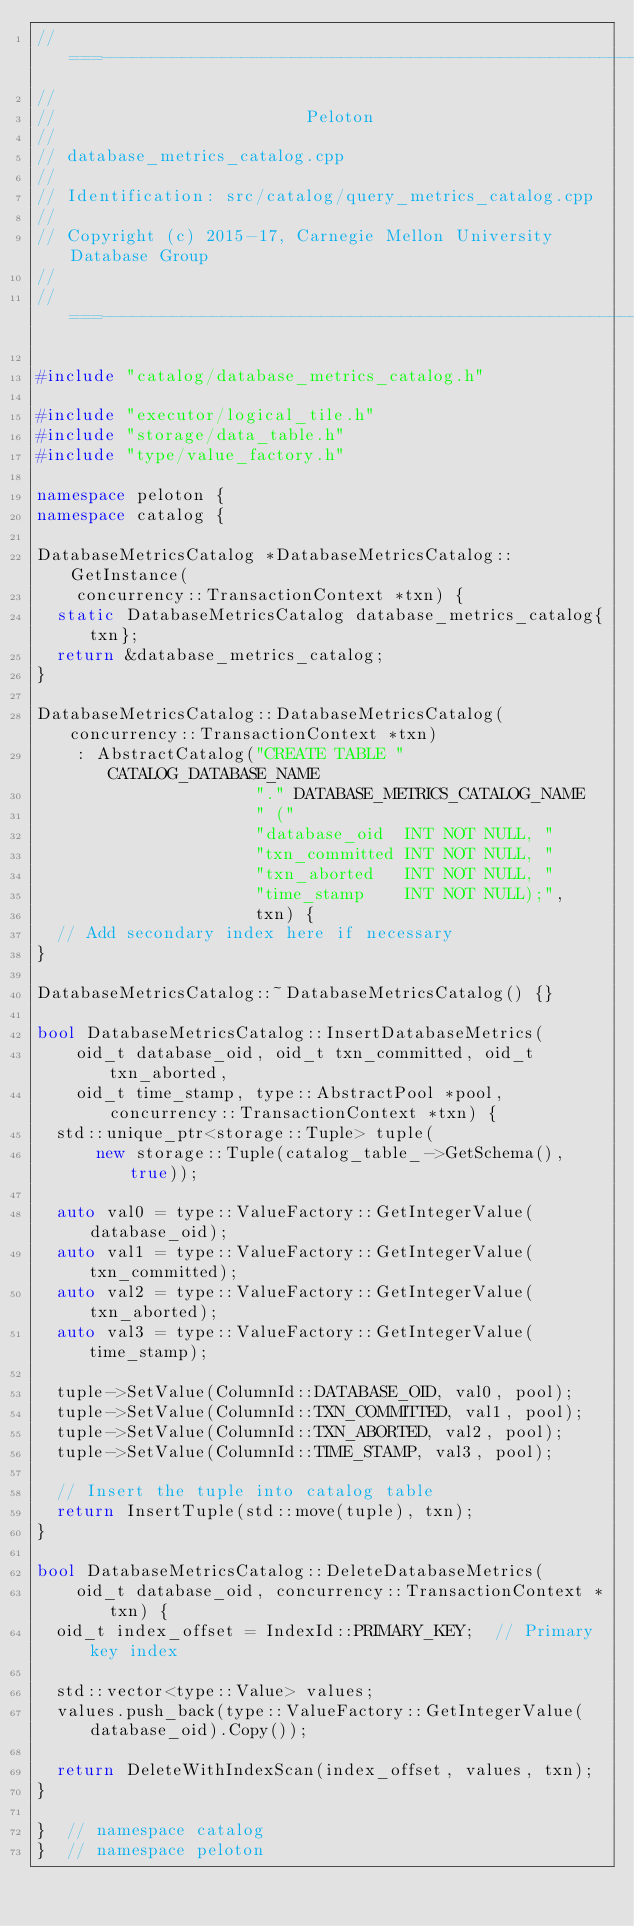<code> <loc_0><loc_0><loc_500><loc_500><_C++_>//===----------------------------------------------------------------------===//
//
//                         Peloton
//
// database_metrics_catalog.cpp
//
// Identification: src/catalog/query_metrics_catalog.cpp
//
// Copyright (c) 2015-17, Carnegie Mellon University Database Group
//
//===----------------------------------------------------------------------===//

#include "catalog/database_metrics_catalog.h"

#include "executor/logical_tile.h"
#include "storage/data_table.h"
#include "type/value_factory.h"

namespace peloton {
namespace catalog {

DatabaseMetricsCatalog *DatabaseMetricsCatalog::GetInstance(
    concurrency::TransactionContext *txn) {
  static DatabaseMetricsCatalog database_metrics_catalog{txn};
  return &database_metrics_catalog;
}

DatabaseMetricsCatalog::DatabaseMetricsCatalog(concurrency::TransactionContext *txn)
    : AbstractCatalog("CREATE TABLE " CATALOG_DATABASE_NAME
                      "." DATABASE_METRICS_CATALOG_NAME
                      " ("
                      "database_oid  INT NOT NULL, "
                      "txn_committed INT NOT NULL, "
                      "txn_aborted   INT NOT NULL, "
                      "time_stamp    INT NOT NULL);",
                      txn) {
  // Add secondary index here if necessary
}

DatabaseMetricsCatalog::~DatabaseMetricsCatalog() {}

bool DatabaseMetricsCatalog::InsertDatabaseMetrics(
    oid_t database_oid, oid_t txn_committed, oid_t txn_aborted,
    oid_t time_stamp, type::AbstractPool *pool, concurrency::TransactionContext *txn) {
  std::unique_ptr<storage::Tuple> tuple(
      new storage::Tuple(catalog_table_->GetSchema(), true));

  auto val0 = type::ValueFactory::GetIntegerValue(database_oid);
  auto val1 = type::ValueFactory::GetIntegerValue(txn_committed);
  auto val2 = type::ValueFactory::GetIntegerValue(txn_aborted);
  auto val3 = type::ValueFactory::GetIntegerValue(time_stamp);

  tuple->SetValue(ColumnId::DATABASE_OID, val0, pool);
  tuple->SetValue(ColumnId::TXN_COMMITTED, val1, pool);
  tuple->SetValue(ColumnId::TXN_ABORTED, val2, pool);
  tuple->SetValue(ColumnId::TIME_STAMP, val3, pool);

  // Insert the tuple into catalog table
  return InsertTuple(std::move(tuple), txn);
}

bool DatabaseMetricsCatalog::DeleteDatabaseMetrics(
    oid_t database_oid, concurrency::TransactionContext *txn) {
  oid_t index_offset = IndexId::PRIMARY_KEY;  // Primary key index

  std::vector<type::Value> values;
  values.push_back(type::ValueFactory::GetIntegerValue(database_oid).Copy());

  return DeleteWithIndexScan(index_offset, values, txn);
}

}  // namespace catalog
}  // namespace peloton</code> 